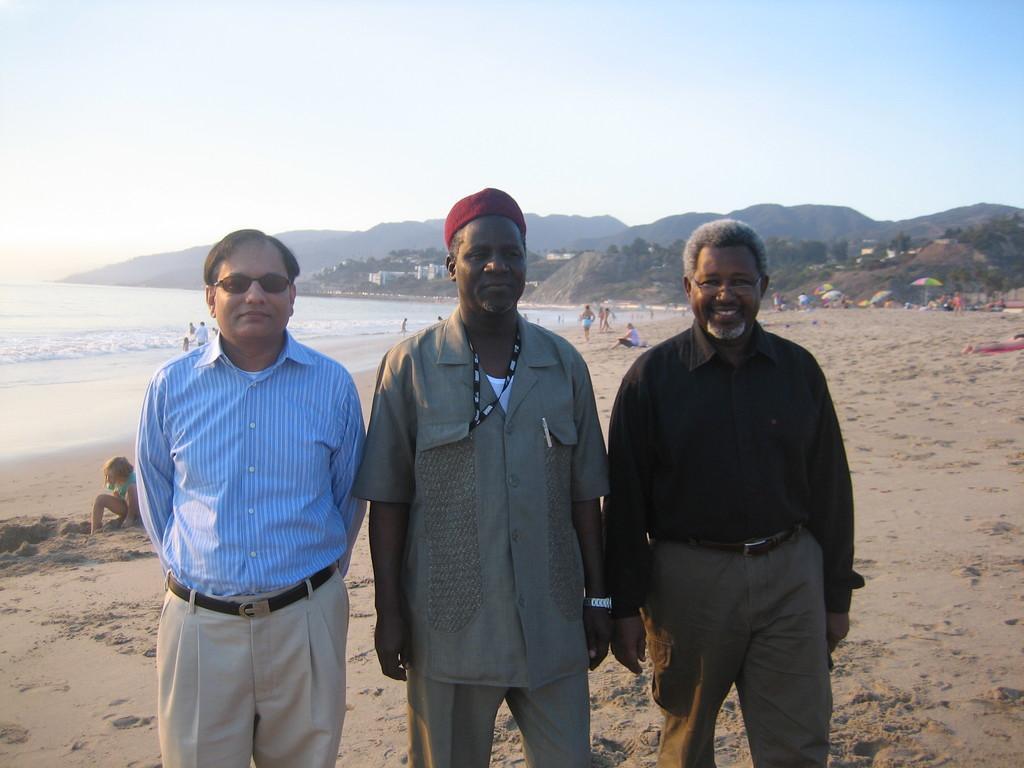Could you give a brief overview of what you see in this image? In this image we can see men standing on the seashore. In the background we can see people sitting and standing on the seashore, sea, hills, buildings, parasols and sky. 